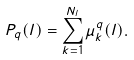Convert formula to latex. <formula><loc_0><loc_0><loc_500><loc_500>P _ { q } ( l ) = \sum _ { k = 1 } ^ { N _ { l } } \mu _ { k } ^ { q } ( l ) .</formula> 